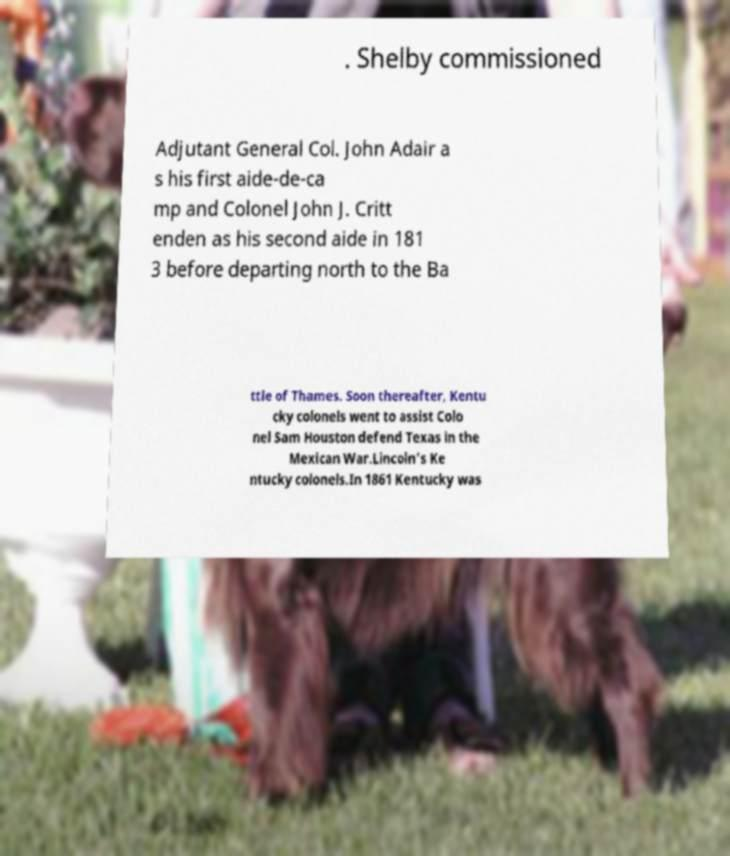Can you read and provide the text displayed in the image?This photo seems to have some interesting text. Can you extract and type it out for me? . Shelby commissioned Adjutant General Col. John Adair a s his first aide-de-ca mp and Colonel John J. Critt enden as his second aide in 181 3 before departing north to the Ba ttle of Thames. Soon thereafter, Kentu cky colonels went to assist Colo nel Sam Houston defend Texas in the Mexican War.Lincoln's Ke ntucky colonels.In 1861 Kentucky was 